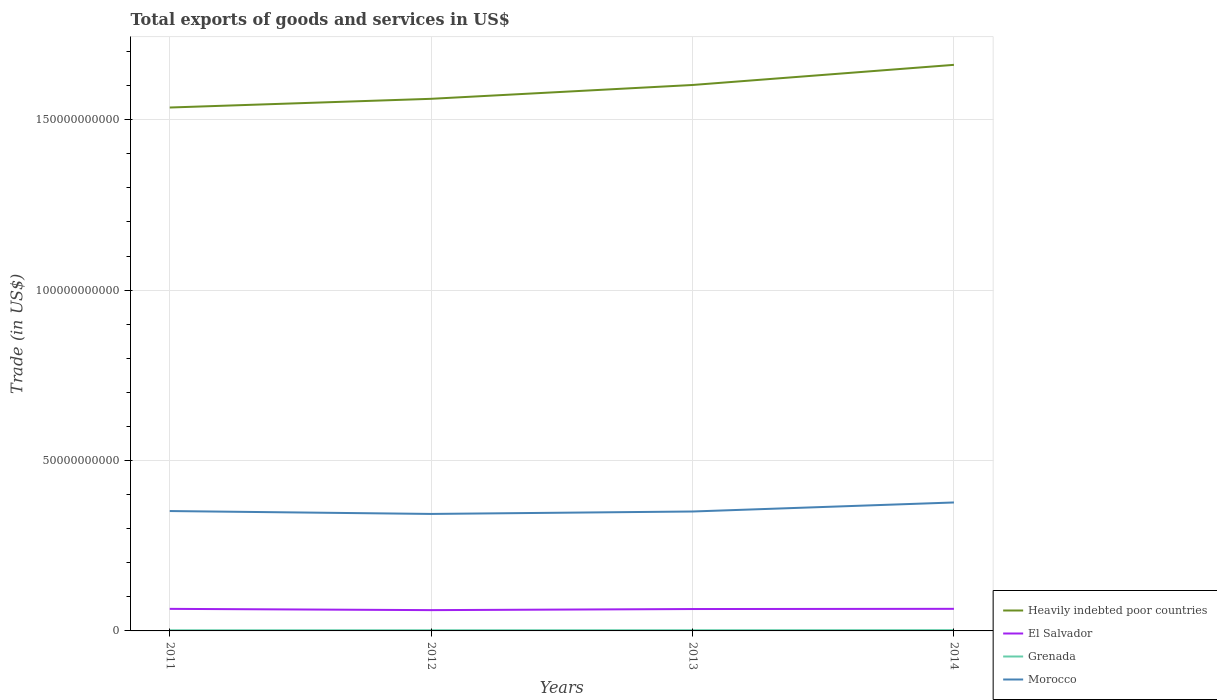How many different coloured lines are there?
Provide a succinct answer. 4. Does the line corresponding to Grenada intersect with the line corresponding to El Salvador?
Your answer should be very brief. No. Across all years, what is the maximum total exports of goods and services in Grenada?
Make the answer very short. 1.96e+08. In which year was the total exports of goods and services in Grenada maximum?
Offer a terse response. 2011. What is the total total exports of goods and services in Grenada in the graph?
Give a very brief answer. -4.14e+07. What is the difference between the highest and the second highest total exports of goods and services in Grenada?
Ensure brevity in your answer.  4.14e+07. What is the difference between the highest and the lowest total exports of goods and services in Heavily indebted poor countries?
Your answer should be very brief. 2. Is the total exports of goods and services in Grenada strictly greater than the total exports of goods and services in El Salvador over the years?
Offer a very short reply. Yes. What is the difference between two consecutive major ticks on the Y-axis?
Provide a succinct answer. 5.00e+1. Are the values on the major ticks of Y-axis written in scientific E-notation?
Offer a very short reply. No. Does the graph contain any zero values?
Offer a very short reply. No. Where does the legend appear in the graph?
Your response must be concise. Bottom right. How many legend labels are there?
Ensure brevity in your answer.  4. What is the title of the graph?
Your answer should be compact. Total exports of goods and services in US$. Does "Kazakhstan" appear as one of the legend labels in the graph?
Make the answer very short. No. What is the label or title of the X-axis?
Ensure brevity in your answer.  Years. What is the label or title of the Y-axis?
Make the answer very short. Trade (in US$). What is the Trade (in US$) in Heavily indebted poor countries in 2011?
Offer a terse response. 1.54e+11. What is the Trade (in US$) in El Salvador in 2011?
Give a very brief answer. 6.47e+09. What is the Trade (in US$) of Grenada in 2011?
Provide a short and direct response. 1.96e+08. What is the Trade (in US$) in Morocco in 2011?
Your answer should be very brief. 3.52e+1. What is the Trade (in US$) in Heavily indebted poor countries in 2012?
Keep it short and to the point. 1.56e+11. What is the Trade (in US$) of El Salvador in 2012?
Ensure brevity in your answer.  6.10e+09. What is the Trade (in US$) in Grenada in 2012?
Ensure brevity in your answer.  2.06e+08. What is the Trade (in US$) in Morocco in 2012?
Your answer should be compact. 3.43e+1. What is the Trade (in US$) in Heavily indebted poor countries in 2013?
Your answer should be compact. 1.60e+11. What is the Trade (in US$) in El Salvador in 2013?
Provide a short and direct response. 6.42e+09. What is the Trade (in US$) in Grenada in 2013?
Offer a terse response. 2.14e+08. What is the Trade (in US$) in Morocco in 2013?
Your answer should be very brief. 3.50e+1. What is the Trade (in US$) of Heavily indebted poor countries in 2014?
Give a very brief answer. 1.66e+11. What is the Trade (in US$) in El Salvador in 2014?
Provide a short and direct response. 6.48e+09. What is the Trade (in US$) in Grenada in 2014?
Ensure brevity in your answer.  2.38e+08. What is the Trade (in US$) of Morocco in 2014?
Make the answer very short. 3.77e+1. Across all years, what is the maximum Trade (in US$) of Heavily indebted poor countries?
Offer a very short reply. 1.66e+11. Across all years, what is the maximum Trade (in US$) of El Salvador?
Offer a very short reply. 6.48e+09. Across all years, what is the maximum Trade (in US$) of Grenada?
Provide a succinct answer. 2.38e+08. Across all years, what is the maximum Trade (in US$) in Morocco?
Provide a succinct answer. 3.77e+1. Across all years, what is the minimum Trade (in US$) of Heavily indebted poor countries?
Offer a terse response. 1.54e+11. Across all years, what is the minimum Trade (in US$) of El Salvador?
Provide a short and direct response. 6.10e+09. Across all years, what is the minimum Trade (in US$) in Grenada?
Provide a short and direct response. 1.96e+08. Across all years, what is the minimum Trade (in US$) of Morocco?
Give a very brief answer. 3.43e+1. What is the total Trade (in US$) of Heavily indebted poor countries in the graph?
Make the answer very short. 6.36e+11. What is the total Trade (in US$) of El Salvador in the graph?
Give a very brief answer. 2.55e+1. What is the total Trade (in US$) in Grenada in the graph?
Provide a short and direct response. 8.54e+08. What is the total Trade (in US$) of Morocco in the graph?
Offer a terse response. 1.42e+11. What is the difference between the Trade (in US$) in Heavily indebted poor countries in 2011 and that in 2012?
Provide a succinct answer. -2.56e+09. What is the difference between the Trade (in US$) of El Salvador in 2011 and that in 2012?
Keep it short and to the point. 3.73e+08. What is the difference between the Trade (in US$) in Grenada in 2011 and that in 2012?
Make the answer very short. -1.03e+07. What is the difference between the Trade (in US$) in Morocco in 2011 and that in 2012?
Offer a very short reply. 8.52e+08. What is the difference between the Trade (in US$) in Heavily indebted poor countries in 2011 and that in 2013?
Keep it short and to the point. -6.61e+09. What is the difference between the Trade (in US$) of El Salvador in 2011 and that in 2013?
Provide a succinct answer. 5.26e+07. What is the difference between the Trade (in US$) of Grenada in 2011 and that in 2013?
Your response must be concise. -1.80e+07. What is the difference between the Trade (in US$) of Morocco in 2011 and that in 2013?
Offer a terse response. 1.34e+08. What is the difference between the Trade (in US$) of Heavily indebted poor countries in 2011 and that in 2014?
Provide a succinct answer. -1.25e+1. What is the difference between the Trade (in US$) in El Salvador in 2011 and that in 2014?
Give a very brief answer. -7.40e+06. What is the difference between the Trade (in US$) in Grenada in 2011 and that in 2014?
Provide a succinct answer. -4.14e+07. What is the difference between the Trade (in US$) of Morocco in 2011 and that in 2014?
Provide a succinct answer. -2.52e+09. What is the difference between the Trade (in US$) in Heavily indebted poor countries in 2012 and that in 2013?
Your response must be concise. -4.06e+09. What is the difference between the Trade (in US$) in El Salvador in 2012 and that in 2013?
Make the answer very short. -3.20e+08. What is the difference between the Trade (in US$) of Grenada in 2012 and that in 2013?
Your answer should be compact. -7.73e+06. What is the difference between the Trade (in US$) in Morocco in 2012 and that in 2013?
Ensure brevity in your answer.  -7.18e+08. What is the difference between the Trade (in US$) of Heavily indebted poor countries in 2012 and that in 2014?
Ensure brevity in your answer.  -9.96e+09. What is the difference between the Trade (in US$) of El Salvador in 2012 and that in 2014?
Ensure brevity in your answer.  -3.80e+08. What is the difference between the Trade (in US$) in Grenada in 2012 and that in 2014?
Give a very brief answer. -3.11e+07. What is the difference between the Trade (in US$) in Morocco in 2012 and that in 2014?
Your answer should be compact. -3.37e+09. What is the difference between the Trade (in US$) in Heavily indebted poor countries in 2013 and that in 2014?
Your answer should be compact. -5.91e+09. What is the difference between the Trade (in US$) of El Salvador in 2013 and that in 2014?
Make the answer very short. -6.00e+07. What is the difference between the Trade (in US$) of Grenada in 2013 and that in 2014?
Your answer should be compact. -2.34e+07. What is the difference between the Trade (in US$) in Morocco in 2013 and that in 2014?
Provide a short and direct response. -2.65e+09. What is the difference between the Trade (in US$) in Heavily indebted poor countries in 2011 and the Trade (in US$) in El Salvador in 2012?
Ensure brevity in your answer.  1.47e+11. What is the difference between the Trade (in US$) in Heavily indebted poor countries in 2011 and the Trade (in US$) in Grenada in 2012?
Your answer should be very brief. 1.53e+11. What is the difference between the Trade (in US$) in Heavily indebted poor countries in 2011 and the Trade (in US$) in Morocco in 2012?
Your answer should be compact. 1.19e+11. What is the difference between the Trade (in US$) in El Salvador in 2011 and the Trade (in US$) in Grenada in 2012?
Your answer should be very brief. 6.27e+09. What is the difference between the Trade (in US$) of El Salvador in 2011 and the Trade (in US$) of Morocco in 2012?
Keep it short and to the point. -2.78e+1. What is the difference between the Trade (in US$) in Grenada in 2011 and the Trade (in US$) in Morocco in 2012?
Provide a succinct answer. -3.41e+1. What is the difference between the Trade (in US$) in Heavily indebted poor countries in 2011 and the Trade (in US$) in El Salvador in 2013?
Your answer should be very brief. 1.47e+11. What is the difference between the Trade (in US$) in Heavily indebted poor countries in 2011 and the Trade (in US$) in Grenada in 2013?
Your answer should be compact. 1.53e+11. What is the difference between the Trade (in US$) of Heavily indebted poor countries in 2011 and the Trade (in US$) of Morocco in 2013?
Provide a short and direct response. 1.19e+11. What is the difference between the Trade (in US$) in El Salvador in 2011 and the Trade (in US$) in Grenada in 2013?
Your answer should be very brief. 6.26e+09. What is the difference between the Trade (in US$) of El Salvador in 2011 and the Trade (in US$) of Morocco in 2013?
Keep it short and to the point. -2.86e+1. What is the difference between the Trade (in US$) in Grenada in 2011 and the Trade (in US$) in Morocco in 2013?
Your response must be concise. -3.48e+1. What is the difference between the Trade (in US$) in Heavily indebted poor countries in 2011 and the Trade (in US$) in El Salvador in 2014?
Provide a short and direct response. 1.47e+11. What is the difference between the Trade (in US$) in Heavily indebted poor countries in 2011 and the Trade (in US$) in Grenada in 2014?
Give a very brief answer. 1.53e+11. What is the difference between the Trade (in US$) in Heavily indebted poor countries in 2011 and the Trade (in US$) in Morocco in 2014?
Keep it short and to the point. 1.16e+11. What is the difference between the Trade (in US$) of El Salvador in 2011 and the Trade (in US$) of Grenada in 2014?
Make the answer very short. 6.24e+09. What is the difference between the Trade (in US$) of El Salvador in 2011 and the Trade (in US$) of Morocco in 2014?
Give a very brief answer. -3.12e+1. What is the difference between the Trade (in US$) of Grenada in 2011 and the Trade (in US$) of Morocco in 2014?
Your answer should be very brief. -3.75e+1. What is the difference between the Trade (in US$) in Heavily indebted poor countries in 2012 and the Trade (in US$) in El Salvador in 2013?
Your response must be concise. 1.50e+11. What is the difference between the Trade (in US$) in Heavily indebted poor countries in 2012 and the Trade (in US$) in Grenada in 2013?
Provide a succinct answer. 1.56e+11. What is the difference between the Trade (in US$) of Heavily indebted poor countries in 2012 and the Trade (in US$) of Morocco in 2013?
Your answer should be compact. 1.21e+11. What is the difference between the Trade (in US$) in El Salvador in 2012 and the Trade (in US$) in Grenada in 2013?
Offer a very short reply. 5.89e+09. What is the difference between the Trade (in US$) of El Salvador in 2012 and the Trade (in US$) of Morocco in 2013?
Give a very brief answer. -2.89e+1. What is the difference between the Trade (in US$) in Grenada in 2012 and the Trade (in US$) in Morocco in 2013?
Keep it short and to the point. -3.48e+1. What is the difference between the Trade (in US$) in Heavily indebted poor countries in 2012 and the Trade (in US$) in El Salvador in 2014?
Offer a very short reply. 1.50e+11. What is the difference between the Trade (in US$) of Heavily indebted poor countries in 2012 and the Trade (in US$) of Grenada in 2014?
Give a very brief answer. 1.56e+11. What is the difference between the Trade (in US$) in Heavily indebted poor countries in 2012 and the Trade (in US$) in Morocco in 2014?
Offer a very short reply. 1.18e+11. What is the difference between the Trade (in US$) of El Salvador in 2012 and the Trade (in US$) of Grenada in 2014?
Make the answer very short. 5.86e+09. What is the difference between the Trade (in US$) in El Salvador in 2012 and the Trade (in US$) in Morocco in 2014?
Ensure brevity in your answer.  -3.16e+1. What is the difference between the Trade (in US$) of Grenada in 2012 and the Trade (in US$) of Morocco in 2014?
Your response must be concise. -3.75e+1. What is the difference between the Trade (in US$) in Heavily indebted poor countries in 2013 and the Trade (in US$) in El Salvador in 2014?
Provide a short and direct response. 1.54e+11. What is the difference between the Trade (in US$) of Heavily indebted poor countries in 2013 and the Trade (in US$) of Grenada in 2014?
Provide a short and direct response. 1.60e+11. What is the difference between the Trade (in US$) in Heavily indebted poor countries in 2013 and the Trade (in US$) in Morocco in 2014?
Provide a succinct answer. 1.23e+11. What is the difference between the Trade (in US$) of El Salvador in 2013 and the Trade (in US$) of Grenada in 2014?
Provide a succinct answer. 6.18e+09. What is the difference between the Trade (in US$) of El Salvador in 2013 and the Trade (in US$) of Morocco in 2014?
Offer a terse response. -3.13e+1. What is the difference between the Trade (in US$) in Grenada in 2013 and the Trade (in US$) in Morocco in 2014?
Give a very brief answer. -3.75e+1. What is the average Trade (in US$) in Heavily indebted poor countries per year?
Provide a short and direct response. 1.59e+11. What is the average Trade (in US$) in El Salvador per year?
Your answer should be compact. 6.37e+09. What is the average Trade (in US$) in Grenada per year?
Offer a very short reply. 2.14e+08. What is the average Trade (in US$) in Morocco per year?
Your response must be concise. 3.56e+1. In the year 2011, what is the difference between the Trade (in US$) of Heavily indebted poor countries and Trade (in US$) of El Salvador?
Offer a terse response. 1.47e+11. In the year 2011, what is the difference between the Trade (in US$) in Heavily indebted poor countries and Trade (in US$) in Grenada?
Offer a very short reply. 1.53e+11. In the year 2011, what is the difference between the Trade (in US$) in Heavily indebted poor countries and Trade (in US$) in Morocco?
Provide a succinct answer. 1.18e+11. In the year 2011, what is the difference between the Trade (in US$) in El Salvador and Trade (in US$) in Grenada?
Keep it short and to the point. 6.28e+09. In the year 2011, what is the difference between the Trade (in US$) in El Salvador and Trade (in US$) in Morocco?
Provide a succinct answer. -2.87e+1. In the year 2011, what is the difference between the Trade (in US$) of Grenada and Trade (in US$) of Morocco?
Your response must be concise. -3.50e+1. In the year 2012, what is the difference between the Trade (in US$) in Heavily indebted poor countries and Trade (in US$) in El Salvador?
Your response must be concise. 1.50e+11. In the year 2012, what is the difference between the Trade (in US$) of Heavily indebted poor countries and Trade (in US$) of Grenada?
Make the answer very short. 1.56e+11. In the year 2012, what is the difference between the Trade (in US$) of Heavily indebted poor countries and Trade (in US$) of Morocco?
Your answer should be compact. 1.22e+11. In the year 2012, what is the difference between the Trade (in US$) in El Salvador and Trade (in US$) in Grenada?
Make the answer very short. 5.90e+09. In the year 2012, what is the difference between the Trade (in US$) of El Salvador and Trade (in US$) of Morocco?
Your answer should be very brief. -2.82e+1. In the year 2012, what is the difference between the Trade (in US$) of Grenada and Trade (in US$) of Morocco?
Offer a terse response. -3.41e+1. In the year 2013, what is the difference between the Trade (in US$) in Heavily indebted poor countries and Trade (in US$) in El Salvador?
Your answer should be very brief. 1.54e+11. In the year 2013, what is the difference between the Trade (in US$) of Heavily indebted poor countries and Trade (in US$) of Grenada?
Your answer should be compact. 1.60e+11. In the year 2013, what is the difference between the Trade (in US$) in Heavily indebted poor countries and Trade (in US$) in Morocco?
Give a very brief answer. 1.25e+11. In the year 2013, what is the difference between the Trade (in US$) of El Salvador and Trade (in US$) of Grenada?
Provide a succinct answer. 6.21e+09. In the year 2013, what is the difference between the Trade (in US$) in El Salvador and Trade (in US$) in Morocco?
Your answer should be very brief. -2.86e+1. In the year 2013, what is the difference between the Trade (in US$) in Grenada and Trade (in US$) in Morocco?
Provide a short and direct response. -3.48e+1. In the year 2014, what is the difference between the Trade (in US$) in Heavily indebted poor countries and Trade (in US$) in El Salvador?
Provide a succinct answer. 1.60e+11. In the year 2014, what is the difference between the Trade (in US$) of Heavily indebted poor countries and Trade (in US$) of Grenada?
Your response must be concise. 1.66e+11. In the year 2014, what is the difference between the Trade (in US$) in Heavily indebted poor countries and Trade (in US$) in Morocco?
Ensure brevity in your answer.  1.28e+11. In the year 2014, what is the difference between the Trade (in US$) of El Salvador and Trade (in US$) of Grenada?
Your response must be concise. 6.24e+09. In the year 2014, what is the difference between the Trade (in US$) in El Salvador and Trade (in US$) in Morocco?
Offer a very short reply. -3.12e+1. In the year 2014, what is the difference between the Trade (in US$) of Grenada and Trade (in US$) of Morocco?
Give a very brief answer. -3.75e+1. What is the ratio of the Trade (in US$) in Heavily indebted poor countries in 2011 to that in 2012?
Offer a terse response. 0.98. What is the ratio of the Trade (in US$) of El Salvador in 2011 to that in 2012?
Your answer should be compact. 1.06. What is the ratio of the Trade (in US$) of Grenada in 2011 to that in 2012?
Give a very brief answer. 0.95. What is the ratio of the Trade (in US$) in Morocco in 2011 to that in 2012?
Your answer should be very brief. 1.02. What is the ratio of the Trade (in US$) in Heavily indebted poor countries in 2011 to that in 2013?
Provide a short and direct response. 0.96. What is the ratio of the Trade (in US$) of El Salvador in 2011 to that in 2013?
Provide a succinct answer. 1.01. What is the ratio of the Trade (in US$) in Grenada in 2011 to that in 2013?
Give a very brief answer. 0.92. What is the ratio of the Trade (in US$) of Heavily indebted poor countries in 2011 to that in 2014?
Provide a succinct answer. 0.92. What is the ratio of the Trade (in US$) in El Salvador in 2011 to that in 2014?
Offer a terse response. 1. What is the ratio of the Trade (in US$) in Grenada in 2011 to that in 2014?
Offer a terse response. 0.83. What is the ratio of the Trade (in US$) of Morocco in 2011 to that in 2014?
Offer a terse response. 0.93. What is the ratio of the Trade (in US$) in Heavily indebted poor countries in 2012 to that in 2013?
Provide a succinct answer. 0.97. What is the ratio of the Trade (in US$) of El Salvador in 2012 to that in 2013?
Your answer should be very brief. 0.95. What is the ratio of the Trade (in US$) of Grenada in 2012 to that in 2013?
Your response must be concise. 0.96. What is the ratio of the Trade (in US$) in Morocco in 2012 to that in 2013?
Give a very brief answer. 0.98. What is the ratio of the Trade (in US$) of Heavily indebted poor countries in 2012 to that in 2014?
Your response must be concise. 0.94. What is the ratio of the Trade (in US$) of El Salvador in 2012 to that in 2014?
Keep it short and to the point. 0.94. What is the ratio of the Trade (in US$) of Grenada in 2012 to that in 2014?
Provide a short and direct response. 0.87. What is the ratio of the Trade (in US$) in Morocco in 2012 to that in 2014?
Keep it short and to the point. 0.91. What is the ratio of the Trade (in US$) in Heavily indebted poor countries in 2013 to that in 2014?
Make the answer very short. 0.96. What is the ratio of the Trade (in US$) of El Salvador in 2013 to that in 2014?
Keep it short and to the point. 0.99. What is the ratio of the Trade (in US$) in Grenada in 2013 to that in 2014?
Provide a short and direct response. 0.9. What is the ratio of the Trade (in US$) in Morocco in 2013 to that in 2014?
Provide a succinct answer. 0.93. What is the difference between the highest and the second highest Trade (in US$) of Heavily indebted poor countries?
Your answer should be very brief. 5.91e+09. What is the difference between the highest and the second highest Trade (in US$) in El Salvador?
Provide a succinct answer. 7.40e+06. What is the difference between the highest and the second highest Trade (in US$) in Grenada?
Provide a short and direct response. 2.34e+07. What is the difference between the highest and the second highest Trade (in US$) of Morocco?
Your answer should be compact. 2.52e+09. What is the difference between the highest and the lowest Trade (in US$) of Heavily indebted poor countries?
Keep it short and to the point. 1.25e+1. What is the difference between the highest and the lowest Trade (in US$) of El Salvador?
Your answer should be compact. 3.80e+08. What is the difference between the highest and the lowest Trade (in US$) in Grenada?
Offer a very short reply. 4.14e+07. What is the difference between the highest and the lowest Trade (in US$) of Morocco?
Offer a terse response. 3.37e+09. 